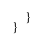<code> <loc_0><loc_0><loc_500><loc_500><_Kotlin_>    }
}


</code> 